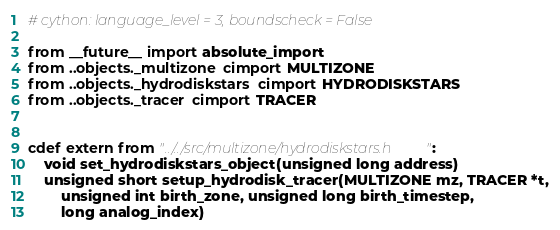Convert code to text. <code><loc_0><loc_0><loc_500><loc_500><_Cython_># cython: language_level = 3, boundscheck = False

from __future__ import absolute_import
from ..objects._multizone cimport MULTIZONE
from ..objects._hydrodiskstars cimport HYDRODISKSTARS
from ..objects._tracer cimport TRACER


cdef extern from "../../src/multizone/hydrodiskstars.h":
	void set_hydrodiskstars_object(unsigned long address)
	unsigned short setup_hydrodisk_tracer(MULTIZONE mz, TRACER *t,
		unsigned int birth_zone, unsigned long birth_timestep,
		long analog_index)

</code> 